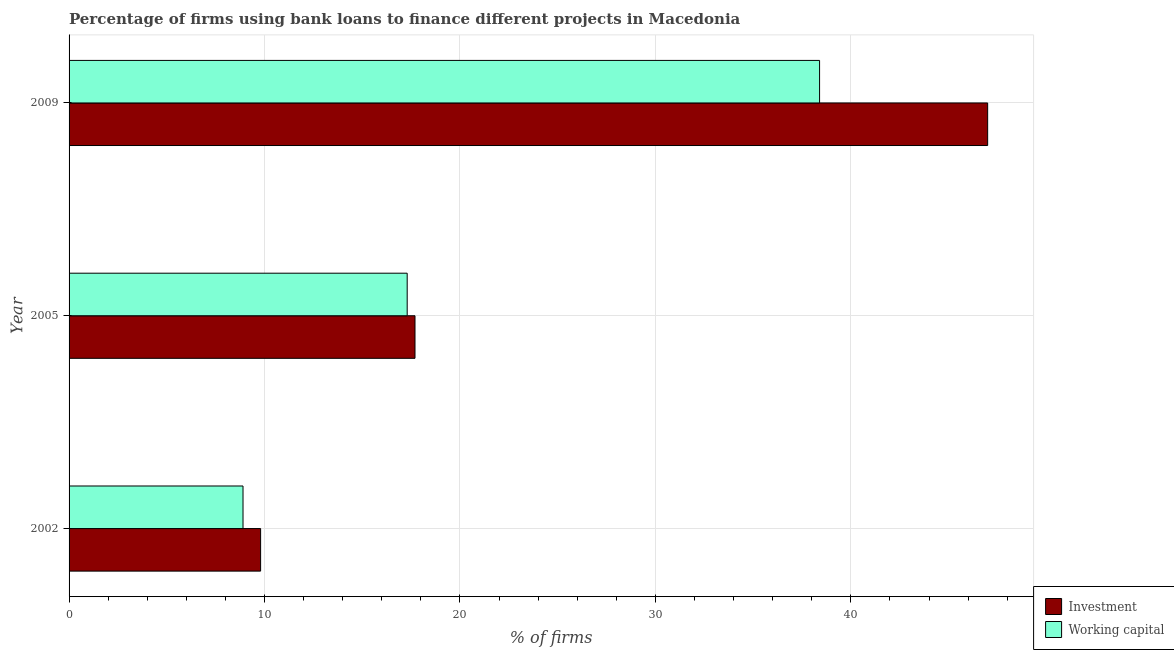Are the number of bars on each tick of the Y-axis equal?
Your answer should be very brief. Yes. How many bars are there on the 2nd tick from the top?
Provide a succinct answer. 2. How many bars are there on the 1st tick from the bottom?
Your answer should be very brief. 2. What is the label of the 3rd group of bars from the top?
Your response must be concise. 2002. Across all years, what is the maximum percentage of firms using banks to finance working capital?
Keep it short and to the point. 38.4. In which year was the percentage of firms using banks to finance investment minimum?
Give a very brief answer. 2002. What is the total percentage of firms using banks to finance working capital in the graph?
Give a very brief answer. 64.6. What is the difference between the percentage of firms using banks to finance investment in 2009 and the percentage of firms using banks to finance working capital in 2002?
Provide a succinct answer. 38.1. What is the average percentage of firms using banks to finance investment per year?
Your answer should be compact. 24.83. What is the ratio of the percentage of firms using banks to finance investment in 2005 to that in 2009?
Provide a short and direct response. 0.38. Is the difference between the percentage of firms using banks to finance investment in 2002 and 2005 greater than the difference between the percentage of firms using banks to finance working capital in 2002 and 2005?
Give a very brief answer. Yes. What is the difference between the highest and the second highest percentage of firms using banks to finance investment?
Keep it short and to the point. 29.3. What is the difference between the highest and the lowest percentage of firms using banks to finance working capital?
Give a very brief answer. 29.5. What does the 1st bar from the top in 2002 represents?
Provide a short and direct response. Working capital. What does the 1st bar from the bottom in 2005 represents?
Your response must be concise. Investment. Are all the bars in the graph horizontal?
Offer a very short reply. Yes. How many years are there in the graph?
Provide a short and direct response. 3. Does the graph contain any zero values?
Offer a terse response. No. Where does the legend appear in the graph?
Offer a terse response. Bottom right. What is the title of the graph?
Give a very brief answer. Percentage of firms using bank loans to finance different projects in Macedonia. Does "Nitrous oxide emissions" appear as one of the legend labels in the graph?
Provide a succinct answer. No. What is the label or title of the X-axis?
Your response must be concise. % of firms. What is the label or title of the Y-axis?
Make the answer very short. Year. What is the % of firms in Working capital in 2002?
Provide a succinct answer. 8.9. What is the % of firms in Investment in 2005?
Provide a succinct answer. 17.7. What is the % of firms in Investment in 2009?
Offer a very short reply. 47. What is the % of firms in Working capital in 2009?
Make the answer very short. 38.4. Across all years, what is the maximum % of firms in Investment?
Provide a short and direct response. 47. Across all years, what is the maximum % of firms of Working capital?
Offer a terse response. 38.4. Across all years, what is the minimum % of firms in Working capital?
Your response must be concise. 8.9. What is the total % of firms in Investment in the graph?
Your answer should be compact. 74.5. What is the total % of firms in Working capital in the graph?
Offer a very short reply. 64.6. What is the difference between the % of firms in Investment in 2002 and that in 2005?
Provide a short and direct response. -7.9. What is the difference between the % of firms in Working capital in 2002 and that in 2005?
Provide a succinct answer. -8.4. What is the difference between the % of firms in Investment in 2002 and that in 2009?
Keep it short and to the point. -37.2. What is the difference between the % of firms in Working capital in 2002 and that in 2009?
Your answer should be compact. -29.5. What is the difference between the % of firms in Investment in 2005 and that in 2009?
Offer a very short reply. -29.3. What is the difference between the % of firms in Working capital in 2005 and that in 2009?
Provide a succinct answer. -21.1. What is the difference between the % of firms of Investment in 2002 and the % of firms of Working capital in 2005?
Give a very brief answer. -7.5. What is the difference between the % of firms in Investment in 2002 and the % of firms in Working capital in 2009?
Offer a very short reply. -28.6. What is the difference between the % of firms in Investment in 2005 and the % of firms in Working capital in 2009?
Keep it short and to the point. -20.7. What is the average % of firms in Investment per year?
Provide a short and direct response. 24.83. What is the average % of firms in Working capital per year?
Provide a short and direct response. 21.53. In the year 2009, what is the difference between the % of firms in Investment and % of firms in Working capital?
Your answer should be very brief. 8.6. What is the ratio of the % of firms in Investment in 2002 to that in 2005?
Give a very brief answer. 0.55. What is the ratio of the % of firms in Working capital in 2002 to that in 2005?
Make the answer very short. 0.51. What is the ratio of the % of firms of Investment in 2002 to that in 2009?
Ensure brevity in your answer.  0.21. What is the ratio of the % of firms of Working capital in 2002 to that in 2009?
Give a very brief answer. 0.23. What is the ratio of the % of firms in Investment in 2005 to that in 2009?
Offer a very short reply. 0.38. What is the ratio of the % of firms in Working capital in 2005 to that in 2009?
Your answer should be very brief. 0.45. What is the difference between the highest and the second highest % of firms of Investment?
Offer a terse response. 29.3. What is the difference between the highest and the second highest % of firms in Working capital?
Give a very brief answer. 21.1. What is the difference between the highest and the lowest % of firms of Investment?
Provide a succinct answer. 37.2. What is the difference between the highest and the lowest % of firms of Working capital?
Provide a succinct answer. 29.5. 